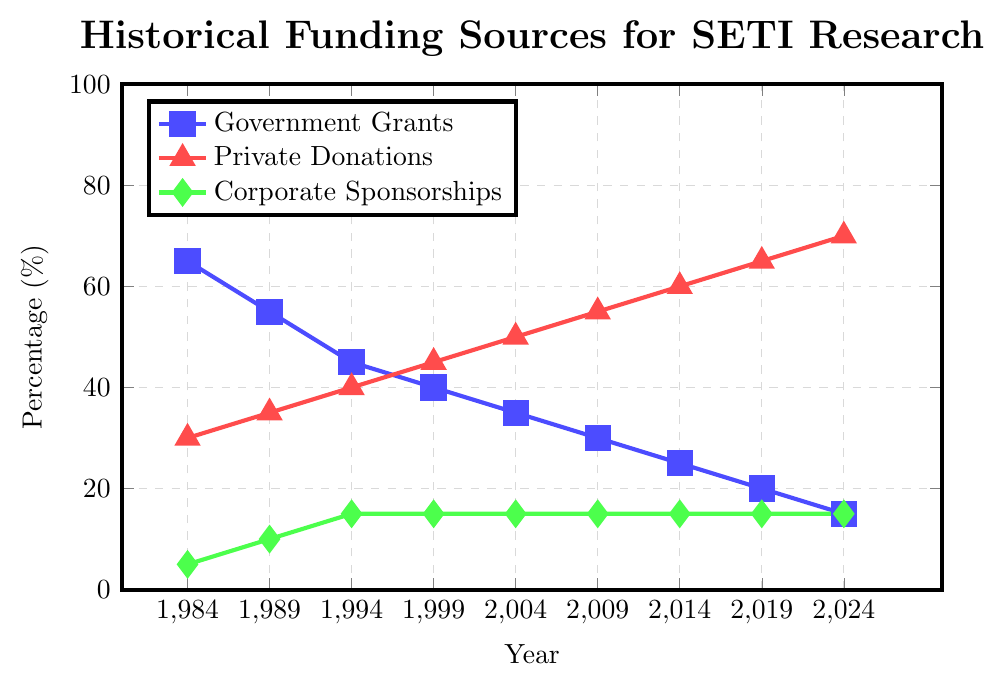What is the trend in government grants from 1984 to 2024? To determine the trend, observe the values of government grants at each data point from 1984 to 2024. Notice that the percentage decreases consistently over time from 65% to 15%.
Answer: Decreasing In which year did private donations surpass government grants? Compare the values of private donations and government grants for each year. In 1999, private donations (45%) equal government grants (40%) and surpass them afterward.
Answer: 1999 By how much did corporate sponsorships increase from 1984 to 1989? Subtract the percentage of corporate sponsorships in 1984 (5%) from the percentage in 1989 (10%). The difference is 5%.
Answer: 5% Which funding source had the most stable percentage over the years? Observe the line representing each funding source. Corporate sponsorships remain flat at 15% from 1994 onwards, indicating the most stability.
Answer: Corporate Sponsorships What is the combined percentage of non-governmental funding sources (private donations and corporate sponsorships) in 2024? Add the percentages of private donations (70%) and corporate sponsorships (15%) in 2024 to get the combined percentage. 70% + 15% = 85%.
Answer: 85% In which period did government grants see the largest decrease in funding percentage? Evaluate the change in government grants between each recorded period. The largest single-period drop is from 1984 (65%) to 1989 (55%), a 10% decrease.
Answer: 1984-1989 How did the gap between private donations and government grants change from 1994 to 2004? Calculate the difference for both years: 1994: 40% (Private Donations) - 45% (Government Grants) = -5%; 2004: 50% (Private Donations) - 35% (Government Grants) = 15%. The gap increased by 20%.
Answer: Increased by 20% What's the difference in the contribution of corporate sponsorships and private donations in 1984? Subtract the percentage of corporate sponsorships (5%) from private donations (30%). 30% - 5% = 25%.
Answer: 25% During which decade did private donations increase the most? Identify the increase for each decade: 1984-1994: 40% - 30% = 10%; 1994-2004: 50% - 40% = 10%; 2004-2014: 60% - 50% = 10%; 2014-2024: 70% - 60% = 10%. All decades show an equal increase.
Answer: All the decades show a 10% increase 